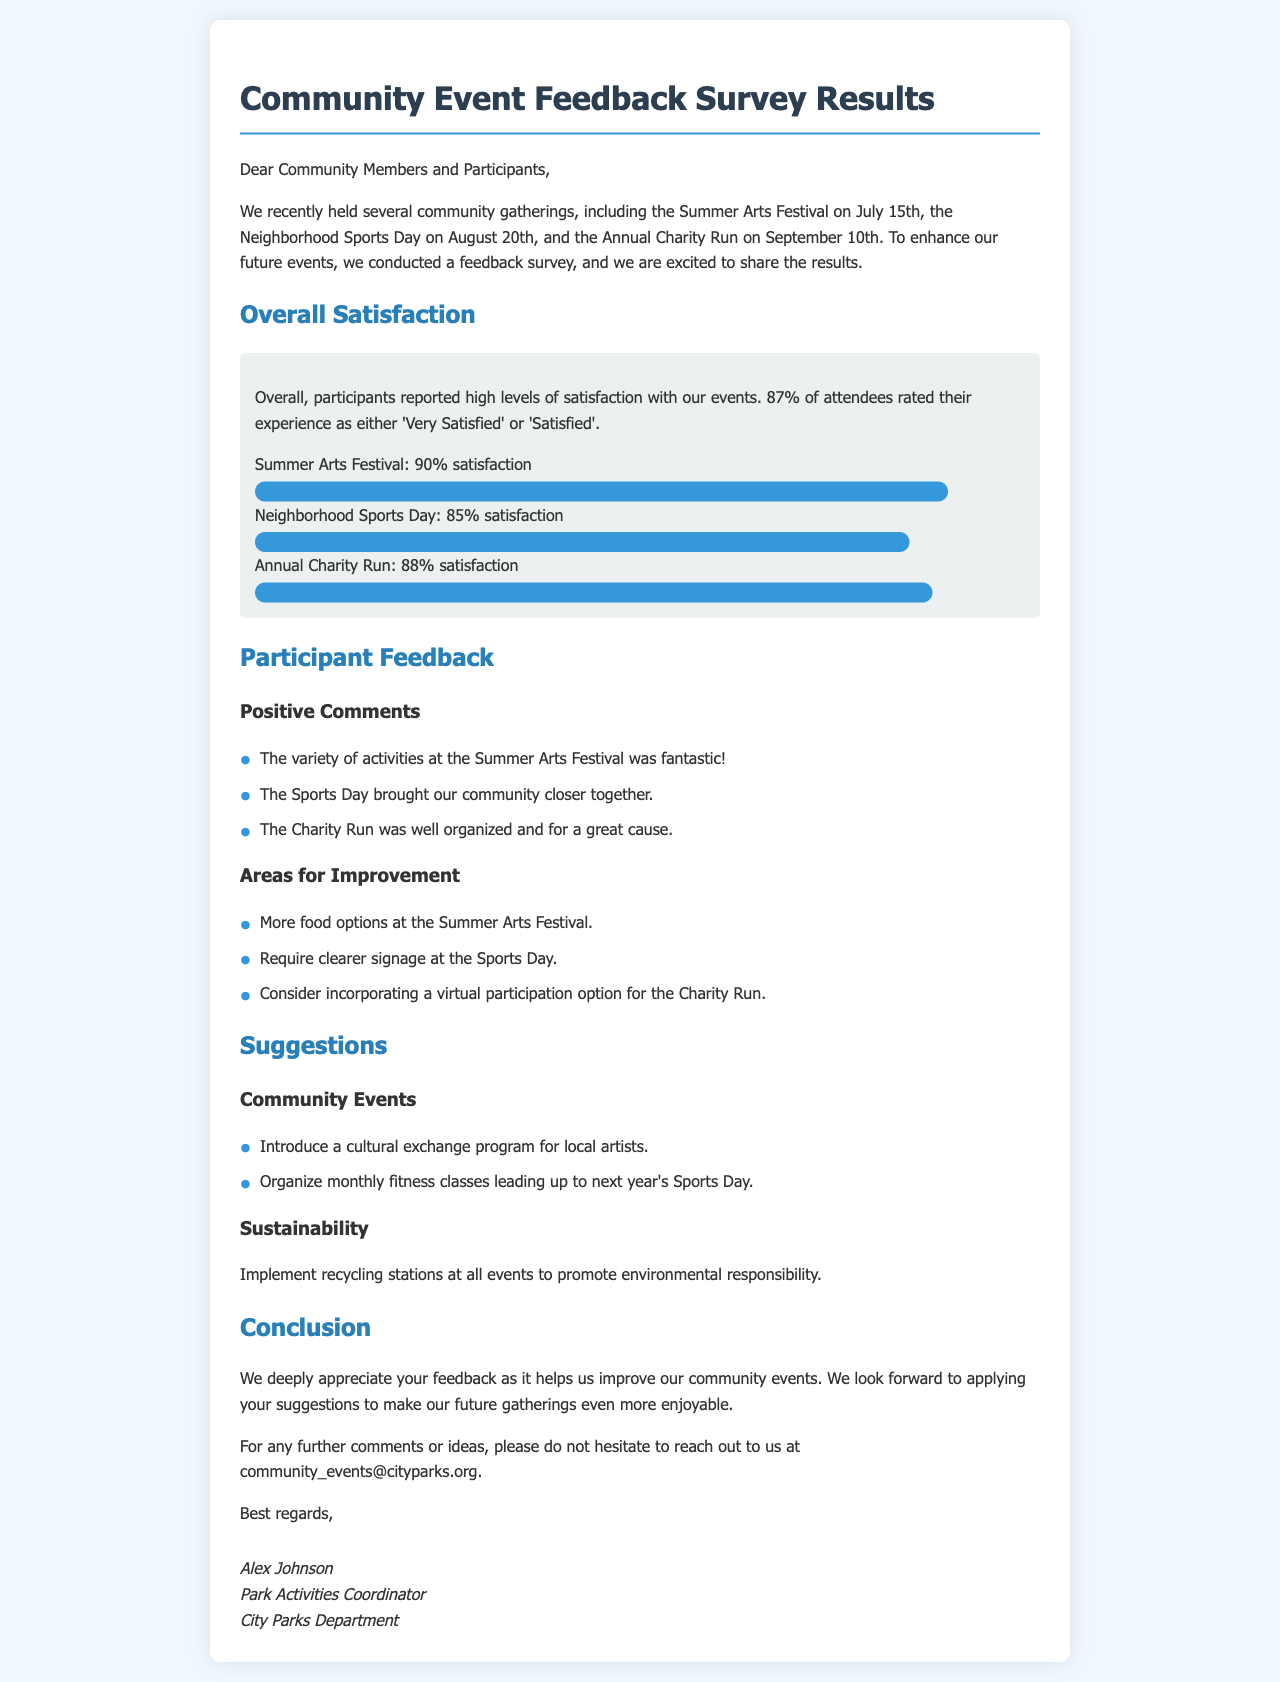What was the overall satisfaction percentage reported by participants? The overall satisfaction percentage reported by participants is stated in the document as 87%.
Answer: 87% Which event had the highest satisfaction rating? The document specifies that the Summer Arts Festival had the highest satisfaction rating at 90%.
Answer: Summer Arts Festival What suggestion was made regarding sustainability? The suggestion regarding sustainability in the document was to implement recycling stations at all events.
Answer: Implement recycling stations What were the dates of the community events mentioned? The community events took place on July 15th, August 20th, and September 10th, as listed in the document.
Answer: July 15th, August 20th, September 10th What was a specific area for improvement mentioned for the Sports Day? A specific area for improvement mentioned for the Sports Day was that clearer signage is required.
Answer: Clearer signage What is the overall sentiment of participant comments regarding the events? The overall sentiment of participant comments is positive, highlighting positive experiences in the document.
Answer: Positive What type of classes does the suggestion recommend organizing leading up to Sports Day? The suggestion recommends organizing monthly fitness classes leading up to next year's Sports Day.
Answer: Monthly fitness classes Who is the Park Activities Coordinator? The document lists Alex Johnson as the Park Activities Coordinator.
Answer: Alex Johnson 